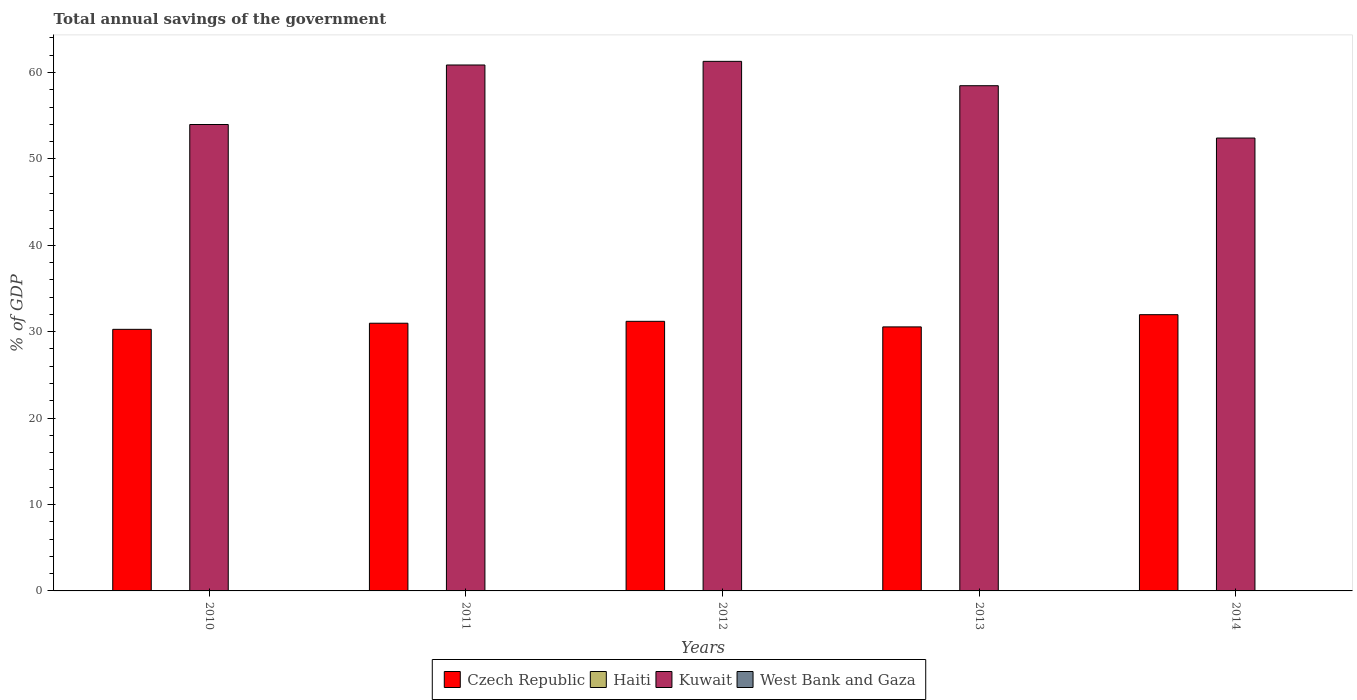Are the number of bars on each tick of the X-axis equal?
Give a very brief answer. Yes. How many bars are there on the 2nd tick from the left?
Provide a short and direct response. 2. What is the total annual savings of the government in Kuwait in 2011?
Give a very brief answer. 60.87. Across all years, what is the maximum total annual savings of the government in Czech Republic?
Give a very brief answer. 31.97. Across all years, what is the minimum total annual savings of the government in Haiti?
Offer a terse response. 0. In which year was the total annual savings of the government in Czech Republic maximum?
Provide a succinct answer. 2014. What is the total total annual savings of the government in Kuwait in the graph?
Your response must be concise. 287.01. What is the difference between the total annual savings of the government in Kuwait in 2011 and that in 2014?
Keep it short and to the point. 8.45. What is the difference between the total annual savings of the government in Kuwait in 2010 and the total annual savings of the government in Haiti in 2014?
Provide a succinct answer. 53.98. What is the ratio of the total annual savings of the government in Czech Republic in 2012 to that in 2013?
Give a very brief answer. 1.02. What is the difference between the highest and the second highest total annual savings of the government in Czech Republic?
Your answer should be very brief. 0.77. What is the difference between the highest and the lowest total annual savings of the government in Czech Republic?
Provide a succinct answer. 1.7. Is the sum of the total annual savings of the government in Czech Republic in 2010 and 2014 greater than the maximum total annual savings of the government in Kuwait across all years?
Offer a terse response. Yes. Is it the case that in every year, the sum of the total annual savings of the government in Haiti and total annual savings of the government in West Bank and Gaza is greater than the total annual savings of the government in Czech Republic?
Keep it short and to the point. No. Are all the bars in the graph horizontal?
Keep it short and to the point. No. What is the difference between two consecutive major ticks on the Y-axis?
Keep it short and to the point. 10. Are the values on the major ticks of Y-axis written in scientific E-notation?
Make the answer very short. No. Does the graph contain any zero values?
Provide a short and direct response. Yes. How are the legend labels stacked?
Offer a very short reply. Horizontal. What is the title of the graph?
Make the answer very short. Total annual savings of the government. What is the label or title of the X-axis?
Your response must be concise. Years. What is the label or title of the Y-axis?
Keep it short and to the point. % of GDP. What is the % of GDP in Czech Republic in 2010?
Provide a succinct answer. 30.27. What is the % of GDP in Kuwait in 2010?
Make the answer very short. 53.98. What is the % of GDP of West Bank and Gaza in 2010?
Your answer should be compact. 0. What is the % of GDP in Czech Republic in 2011?
Offer a very short reply. 30.98. What is the % of GDP of Kuwait in 2011?
Provide a succinct answer. 60.87. What is the % of GDP of West Bank and Gaza in 2011?
Provide a succinct answer. 0. What is the % of GDP in Czech Republic in 2012?
Ensure brevity in your answer.  31.2. What is the % of GDP in Kuwait in 2012?
Offer a terse response. 61.29. What is the % of GDP of Czech Republic in 2013?
Your response must be concise. 30.56. What is the % of GDP of Kuwait in 2013?
Provide a succinct answer. 58.47. What is the % of GDP of Czech Republic in 2014?
Offer a terse response. 31.97. What is the % of GDP in Kuwait in 2014?
Give a very brief answer. 52.41. Across all years, what is the maximum % of GDP of Czech Republic?
Provide a short and direct response. 31.97. Across all years, what is the maximum % of GDP in Kuwait?
Provide a short and direct response. 61.29. Across all years, what is the minimum % of GDP of Czech Republic?
Offer a very short reply. 30.27. Across all years, what is the minimum % of GDP of Kuwait?
Keep it short and to the point. 52.41. What is the total % of GDP of Czech Republic in the graph?
Offer a terse response. 154.98. What is the total % of GDP in Haiti in the graph?
Your answer should be compact. 0. What is the total % of GDP of Kuwait in the graph?
Ensure brevity in your answer.  287.01. What is the difference between the % of GDP of Czech Republic in 2010 and that in 2011?
Offer a terse response. -0.71. What is the difference between the % of GDP of Kuwait in 2010 and that in 2011?
Your answer should be compact. -6.89. What is the difference between the % of GDP of Czech Republic in 2010 and that in 2012?
Provide a short and direct response. -0.93. What is the difference between the % of GDP of Kuwait in 2010 and that in 2012?
Keep it short and to the point. -7.31. What is the difference between the % of GDP of Czech Republic in 2010 and that in 2013?
Make the answer very short. -0.28. What is the difference between the % of GDP in Kuwait in 2010 and that in 2013?
Your response must be concise. -4.49. What is the difference between the % of GDP in Czech Republic in 2010 and that in 2014?
Your answer should be very brief. -1.7. What is the difference between the % of GDP of Kuwait in 2010 and that in 2014?
Your response must be concise. 1.56. What is the difference between the % of GDP in Czech Republic in 2011 and that in 2012?
Provide a short and direct response. -0.22. What is the difference between the % of GDP in Kuwait in 2011 and that in 2012?
Your answer should be compact. -0.42. What is the difference between the % of GDP in Czech Republic in 2011 and that in 2013?
Keep it short and to the point. 0.42. What is the difference between the % of GDP in Kuwait in 2011 and that in 2013?
Provide a succinct answer. 2.4. What is the difference between the % of GDP in Czech Republic in 2011 and that in 2014?
Offer a terse response. -0.99. What is the difference between the % of GDP of Kuwait in 2011 and that in 2014?
Give a very brief answer. 8.45. What is the difference between the % of GDP of Czech Republic in 2012 and that in 2013?
Provide a short and direct response. 0.64. What is the difference between the % of GDP of Kuwait in 2012 and that in 2013?
Give a very brief answer. 2.82. What is the difference between the % of GDP of Czech Republic in 2012 and that in 2014?
Make the answer very short. -0.77. What is the difference between the % of GDP in Kuwait in 2012 and that in 2014?
Offer a very short reply. 8.87. What is the difference between the % of GDP in Czech Republic in 2013 and that in 2014?
Offer a very short reply. -1.41. What is the difference between the % of GDP of Kuwait in 2013 and that in 2014?
Provide a short and direct response. 6.05. What is the difference between the % of GDP of Czech Republic in 2010 and the % of GDP of Kuwait in 2011?
Provide a short and direct response. -30.59. What is the difference between the % of GDP in Czech Republic in 2010 and the % of GDP in Kuwait in 2012?
Give a very brief answer. -31.01. What is the difference between the % of GDP of Czech Republic in 2010 and the % of GDP of Kuwait in 2013?
Your answer should be compact. -28.19. What is the difference between the % of GDP in Czech Republic in 2010 and the % of GDP in Kuwait in 2014?
Offer a very short reply. -22.14. What is the difference between the % of GDP in Czech Republic in 2011 and the % of GDP in Kuwait in 2012?
Keep it short and to the point. -30.31. What is the difference between the % of GDP in Czech Republic in 2011 and the % of GDP in Kuwait in 2013?
Your answer should be compact. -27.49. What is the difference between the % of GDP of Czech Republic in 2011 and the % of GDP of Kuwait in 2014?
Your answer should be compact. -21.43. What is the difference between the % of GDP in Czech Republic in 2012 and the % of GDP in Kuwait in 2013?
Make the answer very short. -27.27. What is the difference between the % of GDP in Czech Republic in 2012 and the % of GDP in Kuwait in 2014?
Provide a short and direct response. -21.21. What is the difference between the % of GDP in Czech Republic in 2013 and the % of GDP in Kuwait in 2014?
Provide a short and direct response. -21.86. What is the average % of GDP in Czech Republic per year?
Provide a succinct answer. 31. What is the average % of GDP in Haiti per year?
Your answer should be very brief. 0. What is the average % of GDP in Kuwait per year?
Provide a succinct answer. 57.4. What is the average % of GDP in West Bank and Gaza per year?
Your answer should be very brief. 0. In the year 2010, what is the difference between the % of GDP in Czech Republic and % of GDP in Kuwait?
Provide a succinct answer. -23.7. In the year 2011, what is the difference between the % of GDP of Czech Republic and % of GDP of Kuwait?
Make the answer very short. -29.89. In the year 2012, what is the difference between the % of GDP in Czech Republic and % of GDP in Kuwait?
Your answer should be compact. -30.09. In the year 2013, what is the difference between the % of GDP in Czech Republic and % of GDP in Kuwait?
Ensure brevity in your answer.  -27.91. In the year 2014, what is the difference between the % of GDP of Czech Republic and % of GDP of Kuwait?
Give a very brief answer. -20.44. What is the ratio of the % of GDP in Czech Republic in 2010 to that in 2011?
Provide a short and direct response. 0.98. What is the ratio of the % of GDP in Kuwait in 2010 to that in 2011?
Your response must be concise. 0.89. What is the ratio of the % of GDP of Czech Republic in 2010 to that in 2012?
Provide a succinct answer. 0.97. What is the ratio of the % of GDP in Kuwait in 2010 to that in 2012?
Make the answer very short. 0.88. What is the ratio of the % of GDP of Kuwait in 2010 to that in 2013?
Your answer should be compact. 0.92. What is the ratio of the % of GDP of Czech Republic in 2010 to that in 2014?
Offer a terse response. 0.95. What is the ratio of the % of GDP of Kuwait in 2010 to that in 2014?
Your answer should be compact. 1.03. What is the ratio of the % of GDP in Kuwait in 2011 to that in 2012?
Your response must be concise. 0.99. What is the ratio of the % of GDP of Czech Republic in 2011 to that in 2013?
Your answer should be very brief. 1.01. What is the ratio of the % of GDP of Kuwait in 2011 to that in 2013?
Keep it short and to the point. 1.04. What is the ratio of the % of GDP in Czech Republic in 2011 to that in 2014?
Give a very brief answer. 0.97. What is the ratio of the % of GDP of Kuwait in 2011 to that in 2014?
Provide a short and direct response. 1.16. What is the ratio of the % of GDP in Czech Republic in 2012 to that in 2013?
Give a very brief answer. 1.02. What is the ratio of the % of GDP in Kuwait in 2012 to that in 2013?
Make the answer very short. 1.05. What is the ratio of the % of GDP in Kuwait in 2012 to that in 2014?
Provide a short and direct response. 1.17. What is the ratio of the % of GDP in Czech Republic in 2013 to that in 2014?
Offer a very short reply. 0.96. What is the ratio of the % of GDP of Kuwait in 2013 to that in 2014?
Provide a short and direct response. 1.12. What is the difference between the highest and the second highest % of GDP of Czech Republic?
Offer a very short reply. 0.77. What is the difference between the highest and the second highest % of GDP in Kuwait?
Offer a terse response. 0.42. What is the difference between the highest and the lowest % of GDP in Czech Republic?
Your answer should be compact. 1.7. What is the difference between the highest and the lowest % of GDP of Kuwait?
Provide a succinct answer. 8.87. 